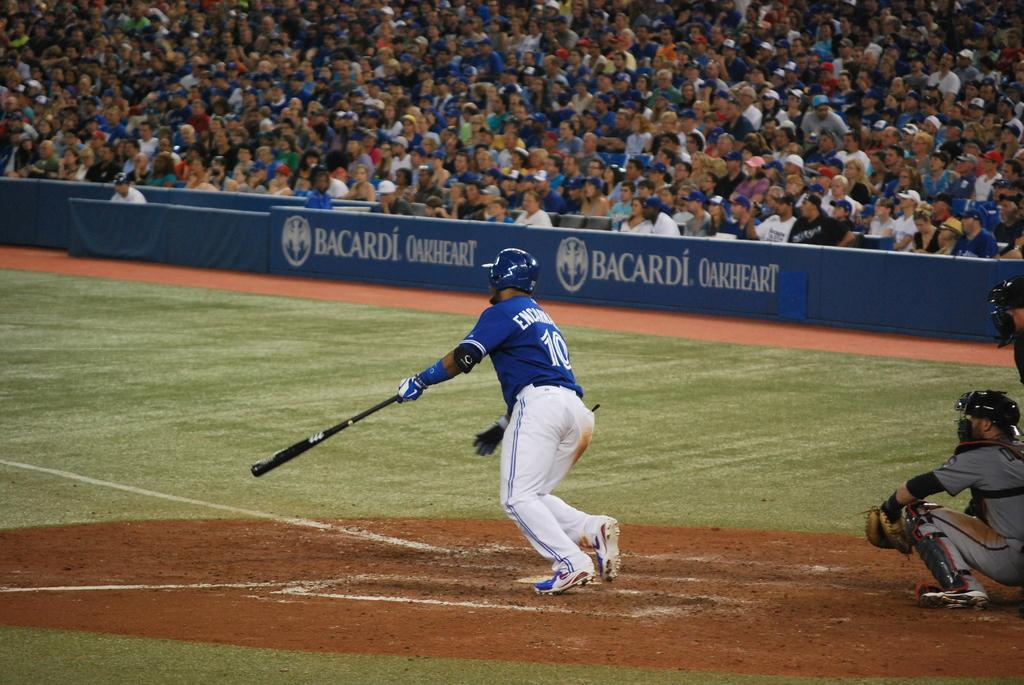<image>
Relay a brief, clear account of the picture shown. A baseball game is underway and the stadium is packed and has a Bacardi Oakheart sign. 